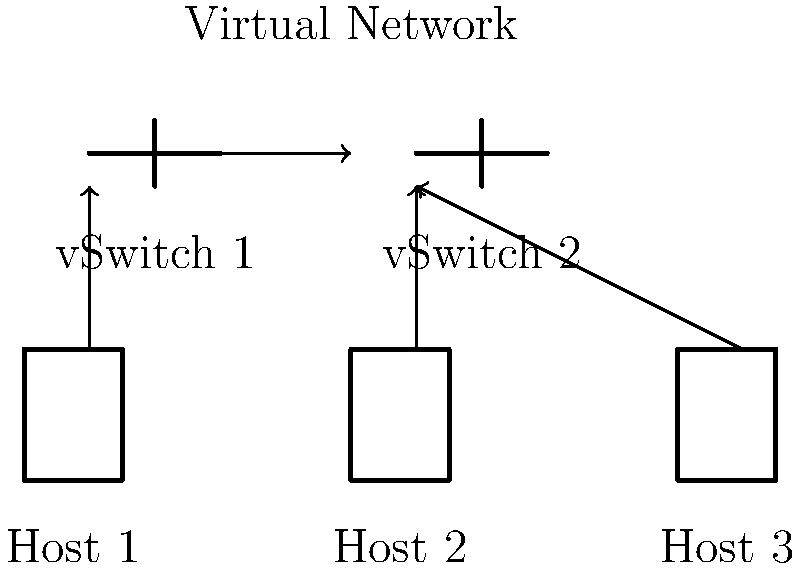Based on the diagram, which network topology is most appropriate for a virtualized environment with multiple hosts and virtual switches? To determine the correct network topology for a virtualized environment, let's analyze the diagram step-by-step:

1. Host Configuration:
   - The diagram shows three physical hosts (Host 1, Host 2, and Host 3).
   - Each host is connected to at least one virtual switch (vSwitch).

2. Virtual Switch Configuration:
   - There are two virtual switches (vSwitch 1 and vSwitch 2).
   - vSwitch 1 connects to Host 1 and Host 2.
   - vSwitch 2 connects to Host 2 and Host 3.

3. Inter-Switch Connection:
   - There is a connection between vSwitch 1 and vSwitch 2, allowing communication between all hosts.

4. Topology Analysis:
   - The hosts are not directly connected to each other.
   - The virtual switches create a layer of abstraction between the physical hosts.
   - The inter-switch connection allows for flexibility and scalability.

5. Virtualization Considerations:
   - This topology supports virtual machine migration between hosts.
   - It allows for network segmentation and isolation of virtual machines.

6. Topology Identification:
   - The arrangement of hosts and switches forms a distributed virtual switch topology.
   - This topology is commonly used in virtualized data centers and cloud environments.

Based on these observations, the most appropriate network topology for this virtualized environment is a Distributed Virtual Switch (DVS) topology. This topology provides centralized management, flexibility, and scalability, which are crucial for virtualized environments.
Answer: Distributed Virtual Switch (DVS) topology 